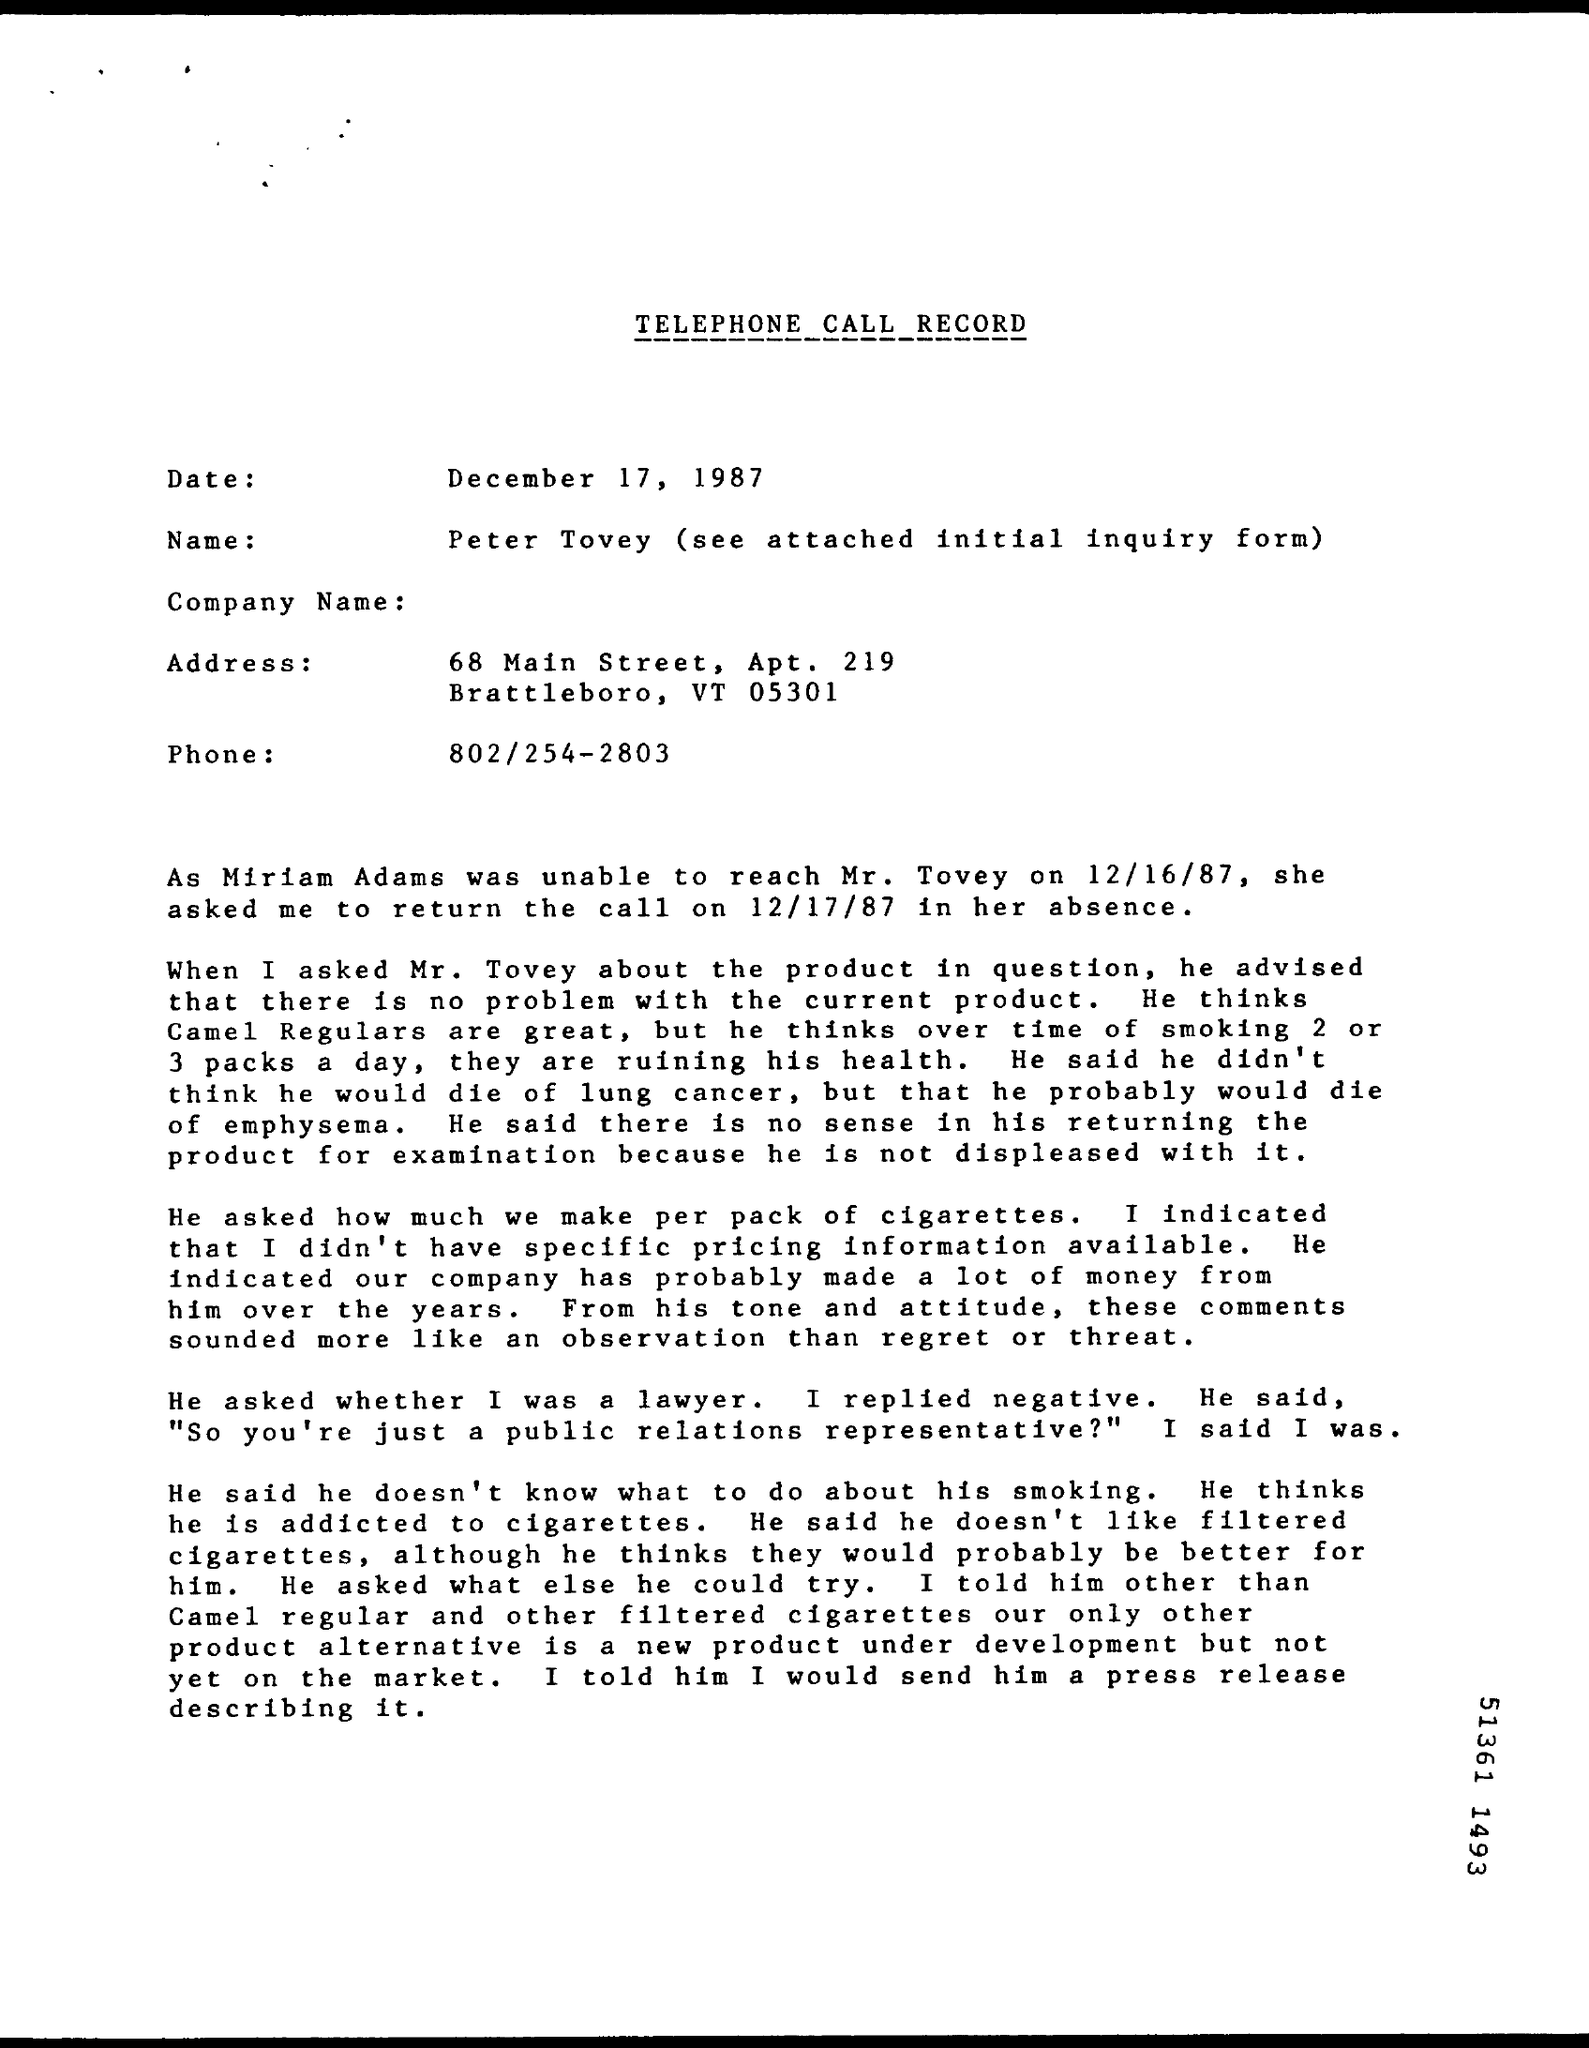List a handful of essential elements in this visual. The name is Peter Tovey. The title of the document is "Telephone Call Record. The date is December 17, 1987. 